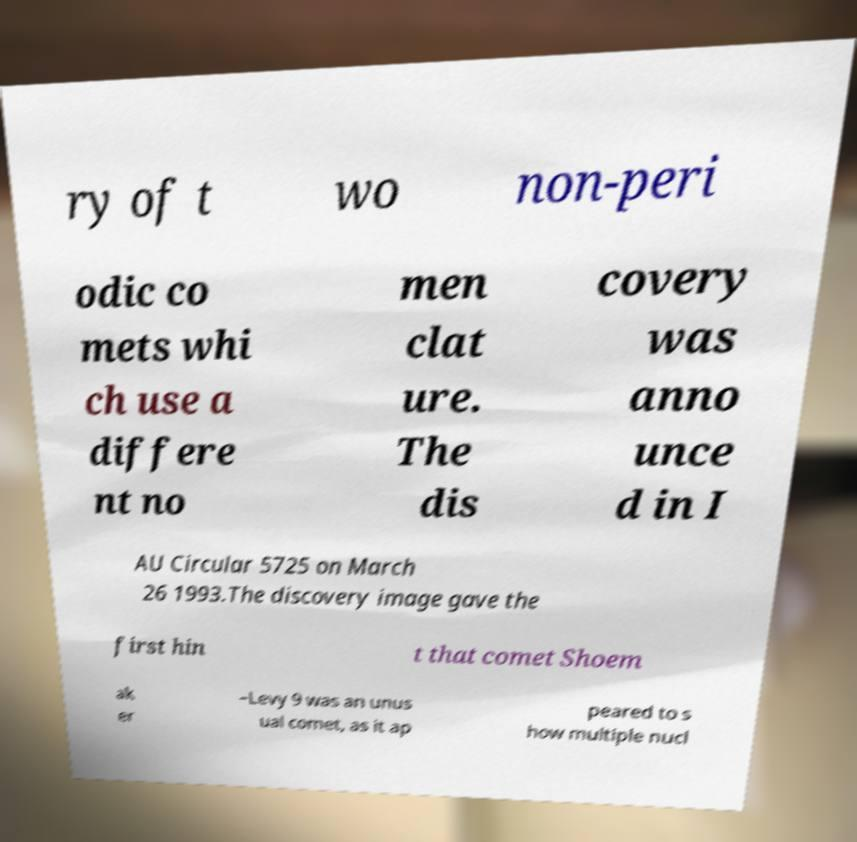Could you extract and type out the text from this image? ry of t wo non-peri odic co mets whi ch use a differe nt no men clat ure. The dis covery was anno unce d in I AU Circular 5725 on March 26 1993.The discovery image gave the first hin t that comet Shoem ak er –Levy 9 was an unus ual comet, as it ap peared to s how multiple nucl 